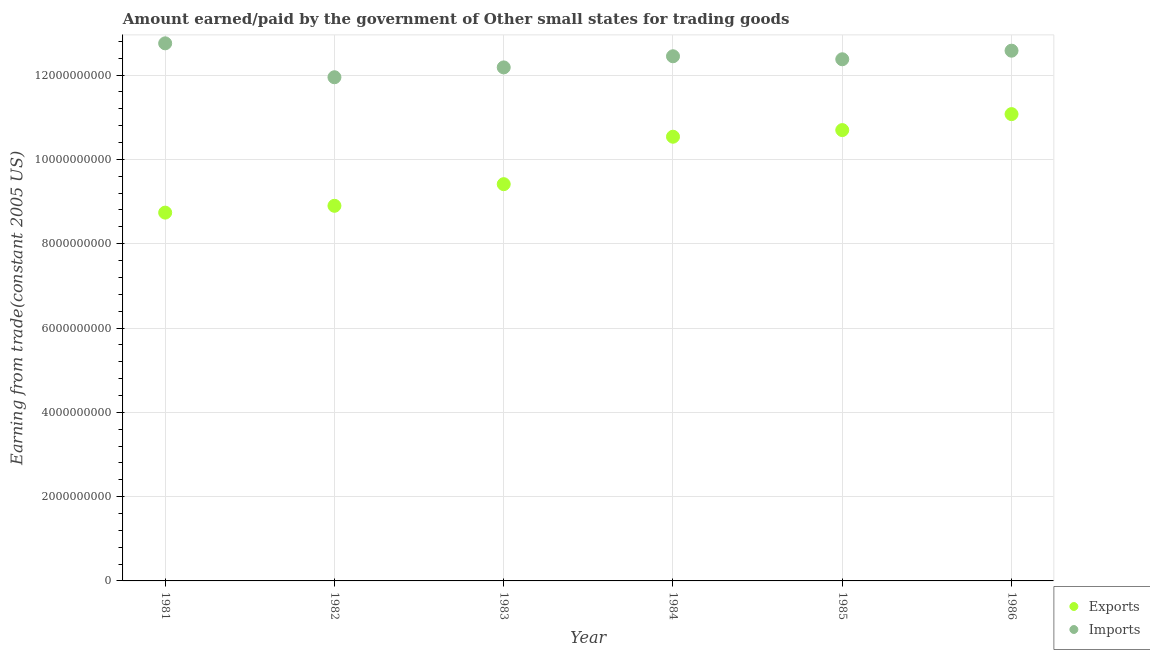What is the amount paid for imports in 1982?
Ensure brevity in your answer.  1.19e+1. Across all years, what is the maximum amount earned from exports?
Ensure brevity in your answer.  1.11e+1. Across all years, what is the minimum amount earned from exports?
Provide a succinct answer. 8.74e+09. In which year was the amount paid for imports maximum?
Offer a very short reply. 1981. In which year was the amount paid for imports minimum?
Provide a short and direct response. 1982. What is the total amount paid for imports in the graph?
Your response must be concise. 7.43e+1. What is the difference between the amount earned from exports in 1983 and that in 1986?
Your response must be concise. -1.66e+09. What is the difference between the amount earned from exports in 1986 and the amount paid for imports in 1984?
Give a very brief answer. -1.37e+09. What is the average amount paid for imports per year?
Your answer should be very brief. 1.24e+1. In the year 1981, what is the difference between the amount earned from exports and amount paid for imports?
Keep it short and to the point. -4.02e+09. What is the ratio of the amount paid for imports in 1982 to that in 1986?
Keep it short and to the point. 0.95. Is the amount earned from exports in 1981 less than that in 1983?
Provide a short and direct response. Yes. Is the difference between the amount paid for imports in 1981 and 1982 greater than the difference between the amount earned from exports in 1981 and 1982?
Ensure brevity in your answer.  Yes. What is the difference between the highest and the second highest amount paid for imports?
Provide a short and direct response. 1.74e+08. What is the difference between the highest and the lowest amount earned from exports?
Provide a succinct answer. 2.34e+09. In how many years, is the amount earned from exports greater than the average amount earned from exports taken over all years?
Your response must be concise. 3. Is the sum of the amount paid for imports in 1982 and 1986 greater than the maximum amount earned from exports across all years?
Ensure brevity in your answer.  Yes. Does the amount paid for imports monotonically increase over the years?
Your response must be concise. No. What is the difference between two consecutive major ticks on the Y-axis?
Offer a very short reply. 2.00e+09. Are the values on the major ticks of Y-axis written in scientific E-notation?
Ensure brevity in your answer.  No. Where does the legend appear in the graph?
Provide a short and direct response. Bottom right. How are the legend labels stacked?
Your response must be concise. Vertical. What is the title of the graph?
Ensure brevity in your answer.  Amount earned/paid by the government of Other small states for trading goods. Does "Female population" appear as one of the legend labels in the graph?
Give a very brief answer. No. What is the label or title of the X-axis?
Ensure brevity in your answer.  Year. What is the label or title of the Y-axis?
Your answer should be very brief. Earning from trade(constant 2005 US). What is the Earning from trade(constant 2005 US) of Exports in 1981?
Ensure brevity in your answer.  8.74e+09. What is the Earning from trade(constant 2005 US) of Imports in 1981?
Offer a very short reply. 1.28e+1. What is the Earning from trade(constant 2005 US) in Exports in 1982?
Offer a very short reply. 8.90e+09. What is the Earning from trade(constant 2005 US) of Imports in 1982?
Your answer should be compact. 1.19e+1. What is the Earning from trade(constant 2005 US) in Exports in 1983?
Your response must be concise. 9.41e+09. What is the Earning from trade(constant 2005 US) in Imports in 1983?
Provide a short and direct response. 1.22e+1. What is the Earning from trade(constant 2005 US) of Exports in 1984?
Give a very brief answer. 1.05e+1. What is the Earning from trade(constant 2005 US) of Imports in 1984?
Your response must be concise. 1.24e+1. What is the Earning from trade(constant 2005 US) in Exports in 1985?
Your response must be concise. 1.07e+1. What is the Earning from trade(constant 2005 US) of Imports in 1985?
Your answer should be compact. 1.24e+1. What is the Earning from trade(constant 2005 US) of Exports in 1986?
Your answer should be compact. 1.11e+1. What is the Earning from trade(constant 2005 US) of Imports in 1986?
Your answer should be compact. 1.26e+1. Across all years, what is the maximum Earning from trade(constant 2005 US) of Exports?
Provide a short and direct response. 1.11e+1. Across all years, what is the maximum Earning from trade(constant 2005 US) of Imports?
Give a very brief answer. 1.28e+1. Across all years, what is the minimum Earning from trade(constant 2005 US) in Exports?
Keep it short and to the point. 8.74e+09. Across all years, what is the minimum Earning from trade(constant 2005 US) of Imports?
Your response must be concise. 1.19e+1. What is the total Earning from trade(constant 2005 US) in Exports in the graph?
Keep it short and to the point. 5.94e+1. What is the total Earning from trade(constant 2005 US) of Imports in the graph?
Offer a very short reply. 7.43e+1. What is the difference between the Earning from trade(constant 2005 US) of Exports in 1981 and that in 1982?
Offer a terse response. -1.62e+08. What is the difference between the Earning from trade(constant 2005 US) of Imports in 1981 and that in 1982?
Your response must be concise. 8.04e+08. What is the difference between the Earning from trade(constant 2005 US) of Exports in 1981 and that in 1983?
Offer a terse response. -6.75e+08. What is the difference between the Earning from trade(constant 2005 US) in Imports in 1981 and that in 1983?
Ensure brevity in your answer.  5.71e+08. What is the difference between the Earning from trade(constant 2005 US) in Exports in 1981 and that in 1984?
Make the answer very short. -1.80e+09. What is the difference between the Earning from trade(constant 2005 US) of Imports in 1981 and that in 1984?
Offer a very short reply. 3.07e+08. What is the difference between the Earning from trade(constant 2005 US) in Exports in 1981 and that in 1985?
Keep it short and to the point. -1.96e+09. What is the difference between the Earning from trade(constant 2005 US) in Imports in 1981 and that in 1985?
Offer a terse response. 3.78e+08. What is the difference between the Earning from trade(constant 2005 US) in Exports in 1981 and that in 1986?
Provide a succinct answer. -2.34e+09. What is the difference between the Earning from trade(constant 2005 US) of Imports in 1981 and that in 1986?
Offer a terse response. 1.74e+08. What is the difference between the Earning from trade(constant 2005 US) of Exports in 1982 and that in 1983?
Your answer should be compact. -5.13e+08. What is the difference between the Earning from trade(constant 2005 US) in Imports in 1982 and that in 1983?
Offer a terse response. -2.33e+08. What is the difference between the Earning from trade(constant 2005 US) of Exports in 1982 and that in 1984?
Your response must be concise. -1.64e+09. What is the difference between the Earning from trade(constant 2005 US) of Imports in 1982 and that in 1984?
Provide a succinct answer. -4.98e+08. What is the difference between the Earning from trade(constant 2005 US) of Exports in 1982 and that in 1985?
Your answer should be very brief. -1.80e+09. What is the difference between the Earning from trade(constant 2005 US) of Imports in 1982 and that in 1985?
Make the answer very short. -4.26e+08. What is the difference between the Earning from trade(constant 2005 US) of Exports in 1982 and that in 1986?
Your answer should be very brief. -2.18e+09. What is the difference between the Earning from trade(constant 2005 US) in Imports in 1982 and that in 1986?
Your answer should be compact. -6.30e+08. What is the difference between the Earning from trade(constant 2005 US) in Exports in 1983 and that in 1984?
Provide a succinct answer. -1.13e+09. What is the difference between the Earning from trade(constant 2005 US) in Imports in 1983 and that in 1984?
Provide a succinct answer. -2.64e+08. What is the difference between the Earning from trade(constant 2005 US) in Exports in 1983 and that in 1985?
Your answer should be compact. -1.28e+09. What is the difference between the Earning from trade(constant 2005 US) of Imports in 1983 and that in 1985?
Provide a succinct answer. -1.93e+08. What is the difference between the Earning from trade(constant 2005 US) in Exports in 1983 and that in 1986?
Offer a very short reply. -1.66e+09. What is the difference between the Earning from trade(constant 2005 US) of Imports in 1983 and that in 1986?
Offer a terse response. -3.97e+08. What is the difference between the Earning from trade(constant 2005 US) of Exports in 1984 and that in 1985?
Make the answer very short. -1.58e+08. What is the difference between the Earning from trade(constant 2005 US) of Imports in 1984 and that in 1985?
Make the answer very short. 7.14e+07. What is the difference between the Earning from trade(constant 2005 US) of Exports in 1984 and that in 1986?
Make the answer very short. -5.37e+08. What is the difference between the Earning from trade(constant 2005 US) of Imports in 1984 and that in 1986?
Make the answer very short. -1.32e+08. What is the difference between the Earning from trade(constant 2005 US) in Exports in 1985 and that in 1986?
Your response must be concise. -3.79e+08. What is the difference between the Earning from trade(constant 2005 US) in Imports in 1985 and that in 1986?
Offer a very short reply. -2.04e+08. What is the difference between the Earning from trade(constant 2005 US) in Exports in 1981 and the Earning from trade(constant 2005 US) in Imports in 1982?
Give a very brief answer. -3.21e+09. What is the difference between the Earning from trade(constant 2005 US) of Exports in 1981 and the Earning from trade(constant 2005 US) of Imports in 1983?
Keep it short and to the point. -3.45e+09. What is the difference between the Earning from trade(constant 2005 US) of Exports in 1981 and the Earning from trade(constant 2005 US) of Imports in 1984?
Keep it short and to the point. -3.71e+09. What is the difference between the Earning from trade(constant 2005 US) in Exports in 1981 and the Earning from trade(constant 2005 US) in Imports in 1985?
Your response must be concise. -3.64e+09. What is the difference between the Earning from trade(constant 2005 US) of Exports in 1981 and the Earning from trade(constant 2005 US) of Imports in 1986?
Your answer should be compact. -3.84e+09. What is the difference between the Earning from trade(constant 2005 US) in Exports in 1982 and the Earning from trade(constant 2005 US) in Imports in 1983?
Your answer should be very brief. -3.28e+09. What is the difference between the Earning from trade(constant 2005 US) in Exports in 1982 and the Earning from trade(constant 2005 US) in Imports in 1984?
Keep it short and to the point. -3.55e+09. What is the difference between the Earning from trade(constant 2005 US) of Exports in 1982 and the Earning from trade(constant 2005 US) of Imports in 1985?
Your answer should be very brief. -3.48e+09. What is the difference between the Earning from trade(constant 2005 US) of Exports in 1982 and the Earning from trade(constant 2005 US) of Imports in 1986?
Provide a short and direct response. -3.68e+09. What is the difference between the Earning from trade(constant 2005 US) in Exports in 1983 and the Earning from trade(constant 2005 US) in Imports in 1984?
Offer a very short reply. -3.03e+09. What is the difference between the Earning from trade(constant 2005 US) in Exports in 1983 and the Earning from trade(constant 2005 US) in Imports in 1985?
Make the answer very short. -2.96e+09. What is the difference between the Earning from trade(constant 2005 US) of Exports in 1983 and the Earning from trade(constant 2005 US) of Imports in 1986?
Make the answer very short. -3.17e+09. What is the difference between the Earning from trade(constant 2005 US) in Exports in 1984 and the Earning from trade(constant 2005 US) in Imports in 1985?
Provide a short and direct response. -1.84e+09. What is the difference between the Earning from trade(constant 2005 US) of Exports in 1984 and the Earning from trade(constant 2005 US) of Imports in 1986?
Your answer should be compact. -2.04e+09. What is the difference between the Earning from trade(constant 2005 US) in Exports in 1985 and the Earning from trade(constant 2005 US) in Imports in 1986?
Provide a short and direct response. -1.88e+09. What is the average Earning from trade(constant 2005 US) of Exports per year?
Keep it short and to the point. 9.89e+09. What is the average Earning from trade(constant 2005 US) in Imports per year?
Your answer should be compact. 1.24e+1. In the year 1981, what is the difference between the Earning from trade(constant 2005 US) in Exports and Earning from trade(constant 2005 US) in Imports?
Provide a succinct answer. -4.02e+09. In the year 1982, what is the difference between the Earning from trade(constant 2005 US) in Exports and Earning from trade(constant 2005 US) in Imports?
Your answer should be compact. -3.05e+09. In the year 1983, what is the difference between the Earning from trade(constant 2005 US) in Exports and Earning from trade(constant 2005 US) in Imports?
Keep it short and to the point. -2.77e+09. In the year 1984, what is the difference between the Earning from trade(constant 2005 US) in Exports and Earning from trade(constant 2005 US) in Imports?
Offer a very short reply. -1.91e+09. In the year 1985, what is the difference between the Earning from trade(constant 2005 US) in Exports and Earning from trade(constant 2005 US) in Imports?
Ensure brevity in your answer.  -1.68e+09. In the year 1986, what is the difference between the Earning from trade(constant 2005 US) of Exports and Earning from trade(constant 2005 US) of Imports?
Your response must be concise. -1.50e+09. What is the ratio of the Earning from trade(constant 2005 US) in Exports in 1981 to that in 1982?
Provide a short and direct response. 0.98. What is the ratio of the Earning from trade(constant 2005 US) in Imports in 1981 to that in 1982?
Keep it short and to the point. 1.07. What is the ratio of the Earning from trade(constant 2005 US) in Exports in 1981 to that in 1983?
Your answer should be very brief. 0.93. What is the ratio of the Earning from trade(constant 2005 US) of Imports in 1981 to that in 1983?
Ensure brevity in your answer.  1.05. What is the ratio of the Earning from trade(constant 2005 US) in Exports in 1981 to that in 1984?
Ensure brevity in your answer.  0.83. What is the ratio of the Earning from trade(constant 2005 US) of Imports in 1981 to that in 1984?
Your answer should be compact. 1.02. What is the ratio of the Earning from trade(constant 2005 US) of Exports in 1981 to that in 1985?
Make the answer very short. 0.82. What is the ratio of the Earning from trade(constant 2005 US) in Imports in 1981 to that in 1985?
Your answer should be very brief. 1.03. What is the ratio of the Earning from trade(constant 2005 US) of Exports in 1981 to that in 1986?
Offer a very short reply. 0.79. What is the ratio of the Earning from trade(constant 2005 US) in Imports in 1981 to that in 1986?
Your answer should be very brief. 1.01. What is the ratio of the Earning from trade(constant 2005 US) in Exports in 1982 to that in 1983?
Provide a succinct answer. 0.95. What is the ratio of the Earning from trade(constant 2005 US) of Imports in 1982 to that in 1983?
Offer a very short reply. 0.98. What is the ratio of the Earning from trade(constant 2005 US) of Exports in 1982 to that in 1984?
Give a very brief answer. 0.84. What is the ratio of the Earning from trade(constant 2005 US) of Imports in 1982 to that in 1984?
Make the answer very short. 0.96. What is the ratio of the Earning from trade(constant 2005 US) in Exports in 1982 to that in 1985?
Your answer should be compact. 0.83. What is the ratio of the Earning from trade(constant 2005 US) of Imports in 1982 to that in 1985?
Offer a terse response. 0.97. What is the ratio of the Earning from trade(constant 2005 US) of Exports in 1982 to that in 1986?
Make the answer very short. 0.8. What is the ratio of the Earning from trade(constant 2005 US) in Imports in 1982 to that in 1986?
Offer a very short reply. 0.95. What is the ratio of the Earning from trade(constant 2005 US) in Exports in 1983 to that in 1984?
Keep it short and to the point. 0.89. What is the ratio of the Earning from trade(constant 2005 US) in Imports in 1983 to that in 1984?
Provide a succinct answer. 0.98. What is the ratio of the Earning from trade(constant 2005 US) in Exports in 1983 to that in 1985?
Offer a terse response. 0.88. What is the ratio of the Earning from trade(constant 2005 US) in Imports in 1983 to that in 1985?
Your answer should be very brief. 0.98. What is the ratio of the Earning from trade(constant 2005 US) in Exports in 1983 to that in 1986?
Your answer should be very brief. 0.85. What is the ratio of the Earning from trade(constant 2005 US) of Imports in 1983 to that in 1986?
Ensure brevity in your answer.  0.97. What is the ratio of the Earning from trade(constant 2005 US) in Exports in 1984 to that in 1985?
Your answer should be very brief. 0.99. What is the ratio of the Earning from trade(constant 2005 US) of Imports in 1984 to that in 1985?
Offer a very short reply. 1.01. What is the ratio of the Earning from trade(constant 2005 US) of Exports in 1984 to that in 1986?
Your answer should be very brief. 0.95. What is the ratio of the Earning from trade(constant 2005 US) of Imports in 1984 to that in 1986?
Offer a very short reply. 0.99. What is the ratio of the Earning from trade(constant 2005 US) of Exports in 1985 to that in 1986?
Your response must be concise. 0.97. What is the ratio of the Earning from trade(constant 2005 US) of Imports in 1985 to that in 1986?
Give a very brief answer. 0.98. What is the difference between the highest and the second highest Earning from trade(constant 2005 US) in Exports?
Your answer should be very brief. 3.79e+08. What is the difference between the highest and the second highest Earning from trade(constant 2005 US) of Imports?
Your answer should be very brief. 1.74e+08. What is the difference between the highest and the lowest Earning from trade(constant 2005 US) of Exports?
Make the answer very short. 2.34e+09. What is the difference between the highest and the lowest Earning from trade(constant 2005 US) of Imports?
Your response must be concise. 8.04e+08. 